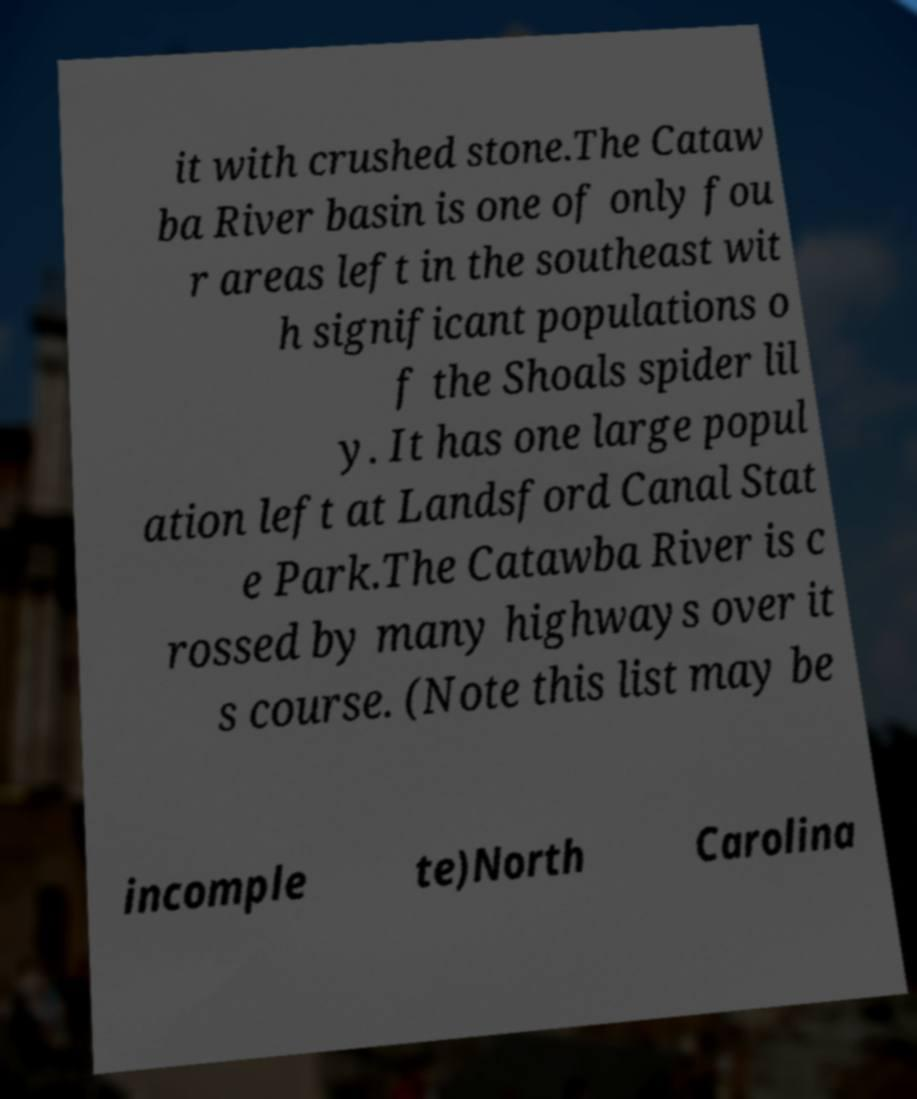Please read and relay the text visible in this image. What does it say? it with crushed stone.The Cataw ba River basin is one of only fou r areas left in the southeast wit h significant populations o f the Shoals spider lil y. It has one large popul ation left at Landsford Canal Stat e Park.The Catawba River is c rossed by many highways over it s course. (Note this list may be incomple te)North Carolina 